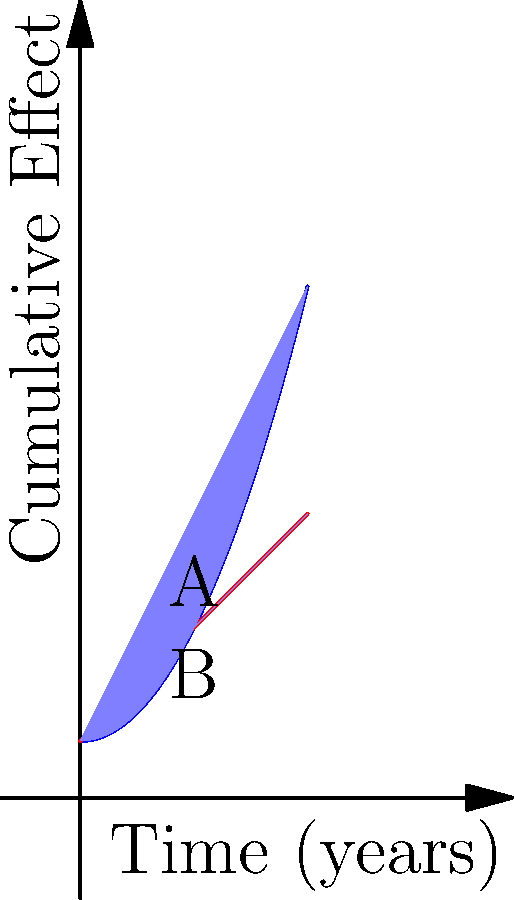Consider the graph above, where the blue curve represents the cumulative effect of leadership decisions over time, and the red line represents linear growth. The shaded area between the curves from year 0 to year 4 represents the additional impact of strategic leadership decisions compared to linear growth. Calculate the value of this additional impact using calculus. To find the additional impact of strategic leadership decisions, we need to calculate the area between the two curves. This can be done using definite integration.

Step 1: Identify the functions
Blue curve (leadership impact): $f(x) = 0.5x^2 + 1$
Red line (linear growth): $g(x) = x + 1$

Step 2: Set up the integral
The area between the curves is given by:
$$\int_0^4 [f(x) - g(x)] dx$$

Step 3: Substitute the functions
$$\int_0^4 [(0.5x^2 + 1) - (x + 1)] dx$$

Step 4: Simplify the integrand
$$\int_0^4 (0.5x^2 - x) dx$$

Step 5: Integrate
$$\left[\frac{1}{6}x^3 - \frac{1}{2}x^2\right]_0^4$$

Step 6: Evaluate the definite integral
$$\left(\frac{1}{6}(4^3) - \frac{1}{2}(4^2)\right) - \left(\frac{1}{6}(0^3) - \frac{1}{2}(0^2)\right)$$
$$= (10.67 - 8) - (0 - 0) = 2.67$$

Therefore, the additional impact of strategic leadership decisions over the 4-year period is approximately 2.67 units.
Answer: 2.67 units 